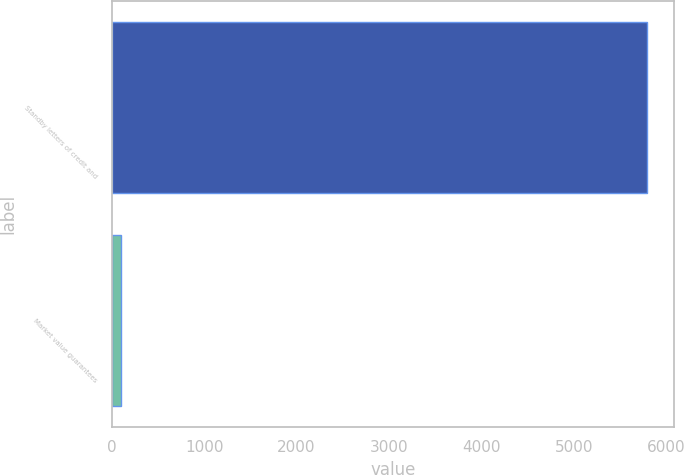Convert chart. <chart><loc_0><loc_0><loc_500><loc_500><bar_chart><fcel>Standby letters of credit and<fcel>Market value guarantees<nl><fcel>5792<fcel>104<nl></chart> 